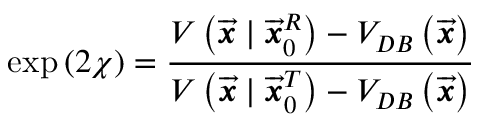Convert formula to latex. <formula><loc_0><loc_0><loc_500><loc_500>\exp \left ( 2 \chi \right ) = \frac { V \left ( \overrightarrow { \mathbf i t { x } } | \overrightarrow { \mathbf i t { x } } _ { 0 } ^ { R } \right ) - V _ { D B } \left ( \overrightarrow { \mathbf i t { x } } \right ) } { V \left ( \overrightarrow { \mathbf i t { x } } | \overrightarrow { \mathbf i t { x } } _ { 0 } ^ { T } \right ) - V _ { D B } \left ( \overrightarrow { \mathbf i t { x } } \right ) }</formula> 